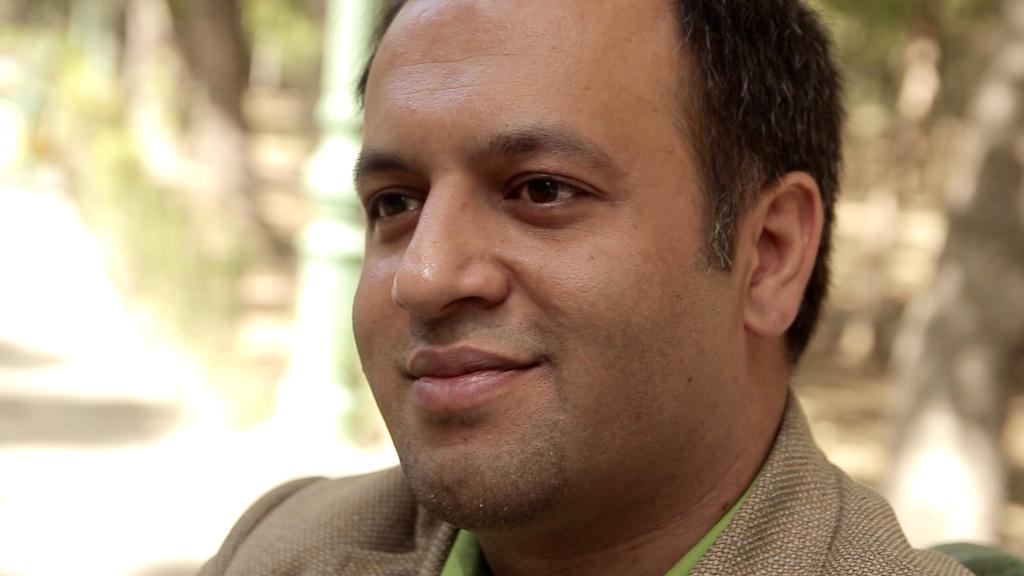What is present in the image? There is a man in the image. Can you describe the man's attire? The man is wearing a brown suit. What can be observed about the background of the image? The background of the image is blurred. Can you tell me how many patches are on the man's suit in the image? There is no mention of patches on the man's suit in the image. What type of fowl can be seen in the image? There is no fowl present in the image. 